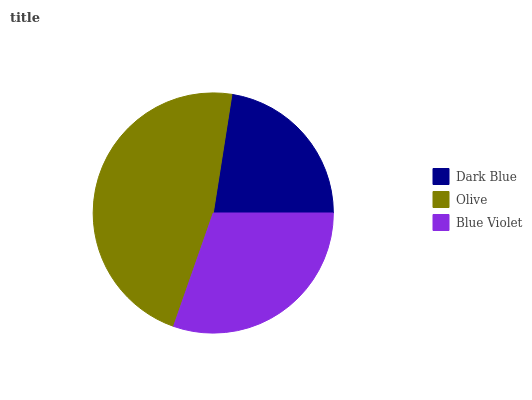Is Dark Blue the minimum?
Answer yes or no. Yes. Is Olive the maximum?
Answer yes or no. Yes. Is Blue Violet the minimum?
Answer yes or no. No. Is Blue Violet the maximum?
Answer yes or no. No. Is Olive greater than Blue Violet?
Answer yes or no. Yes. Is Blue Violet less than Olive?
Answer yes or no. Yes. Is Blue Violet greater than Olive?
Answer yes or no. No. Is Olive less than Blue Violet?
Answer yes or no. No. Is Blue Violet the high median?
Answer yes or no. Yes. Is Blue Violet the low median?
Answer yes or no. Yes. Is Olive the high median?
Answer yes or no. No. Is Olive the low median?
Answer yes or no. No. 